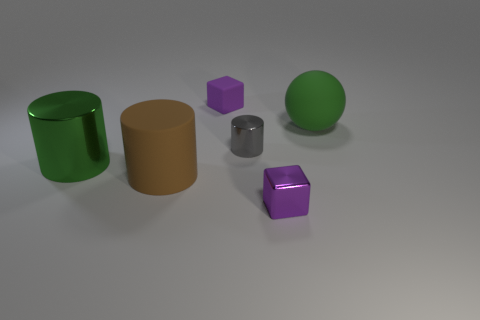Are there any green cylinders right of the tiny purple rubber object?
Make the answer very short. No. Do the tiny gray object and the purple metallic object that is in front of the large brown matte cylinder have the same shape?
Make the answer very short. No. What number of other things are made of the same material as the large green sphere?
Ensure brevity in your answer.  2. What is the color of the shiny cube right of the big matte thing to the left of the purple cube that is in front of the brown rubber cylinder?
Provide a succinct answer. Purple. What is the shape of the large green thing that is in front of the green thing that is to the right of the large brown object?
Provide a succinct answer. Cylinder. Are there more brown cylinders right of the green ball than brown cylinders?
Keep it short and to the point. No. Does the tiny purple thing in front of the large rubber sphere have the same shape as the green rubber object?
Provide a short and direct response. No. Is there a green metallic thing that has the same shape as the large brown thing?
Provide a short and direct response. Yes. How many things are either purple blocks behind the matte cylinder or big purple cylinders?
Keep it short and to the point. 1. Are there more brown objects than tiny purple blocks?
Offer a very short reply. No. 